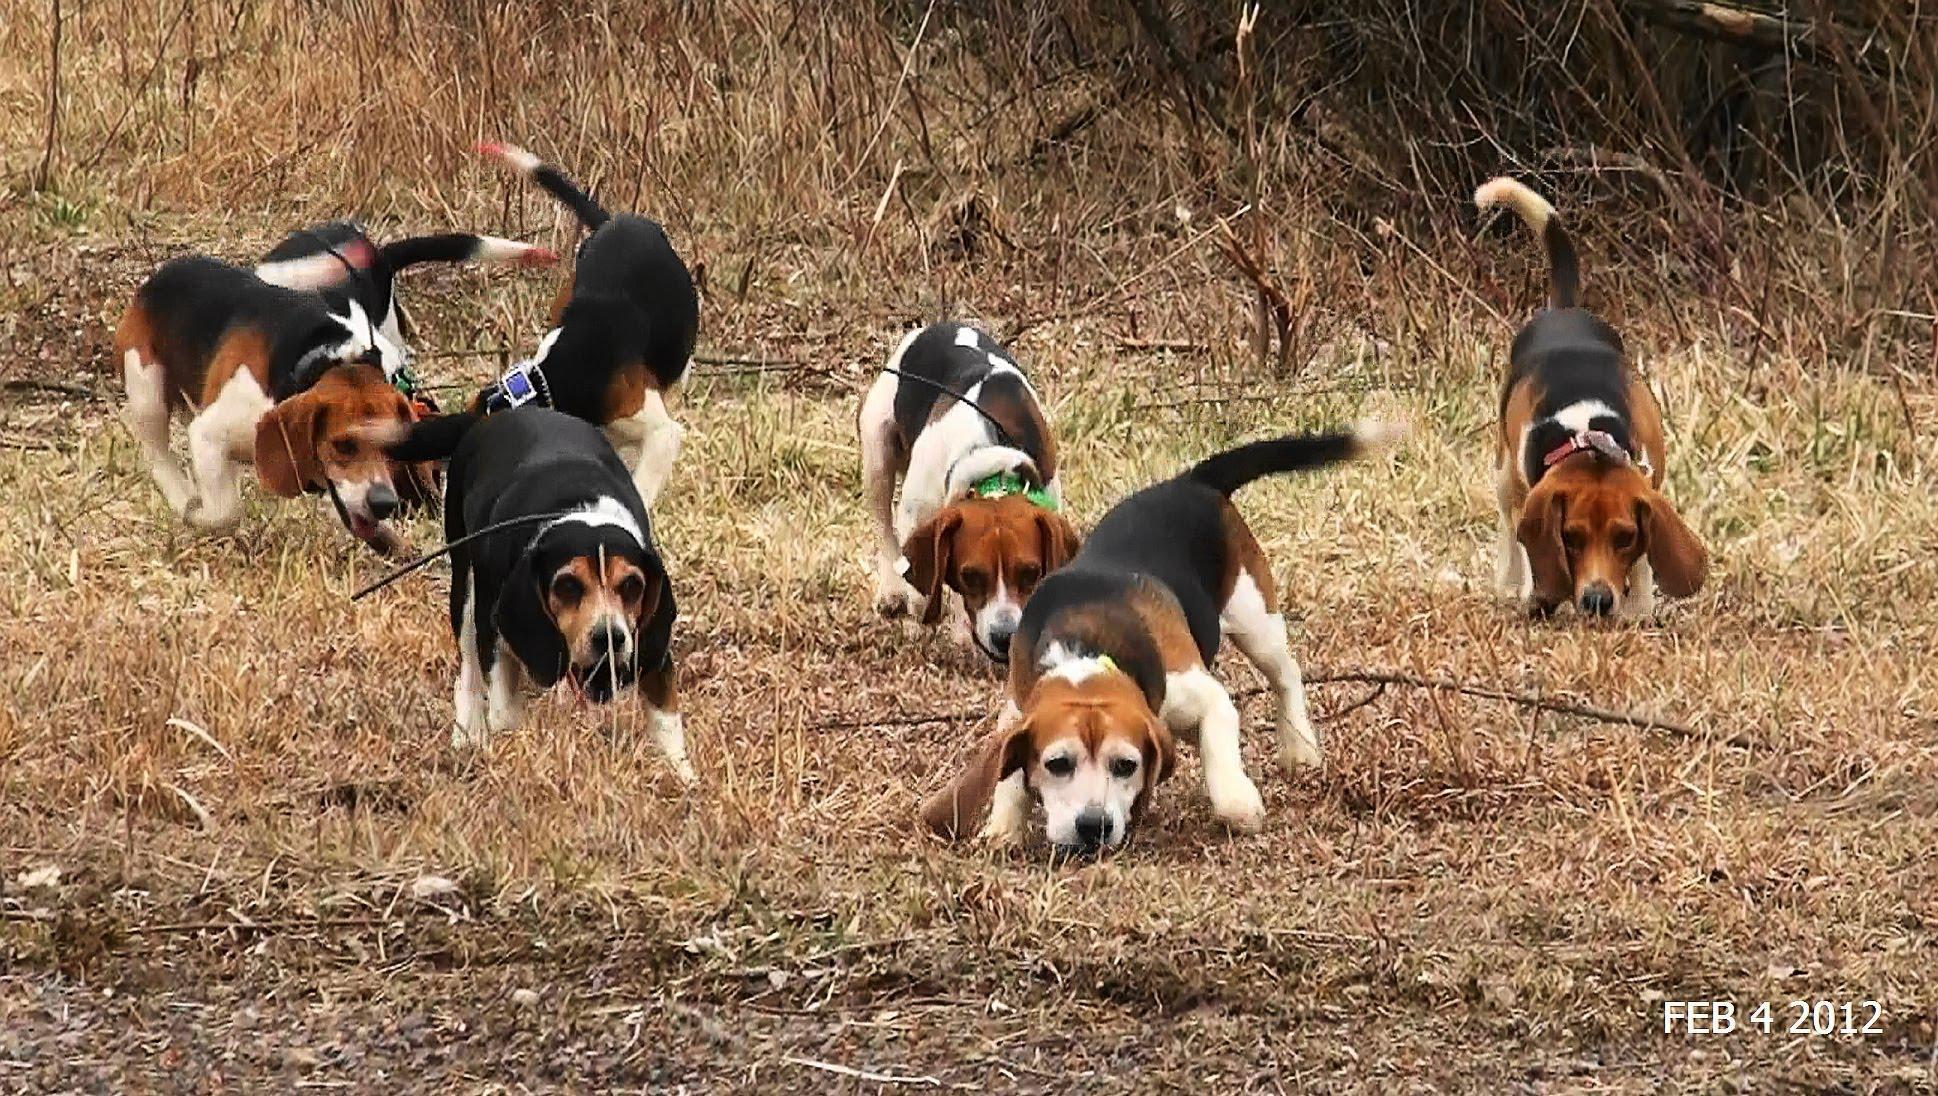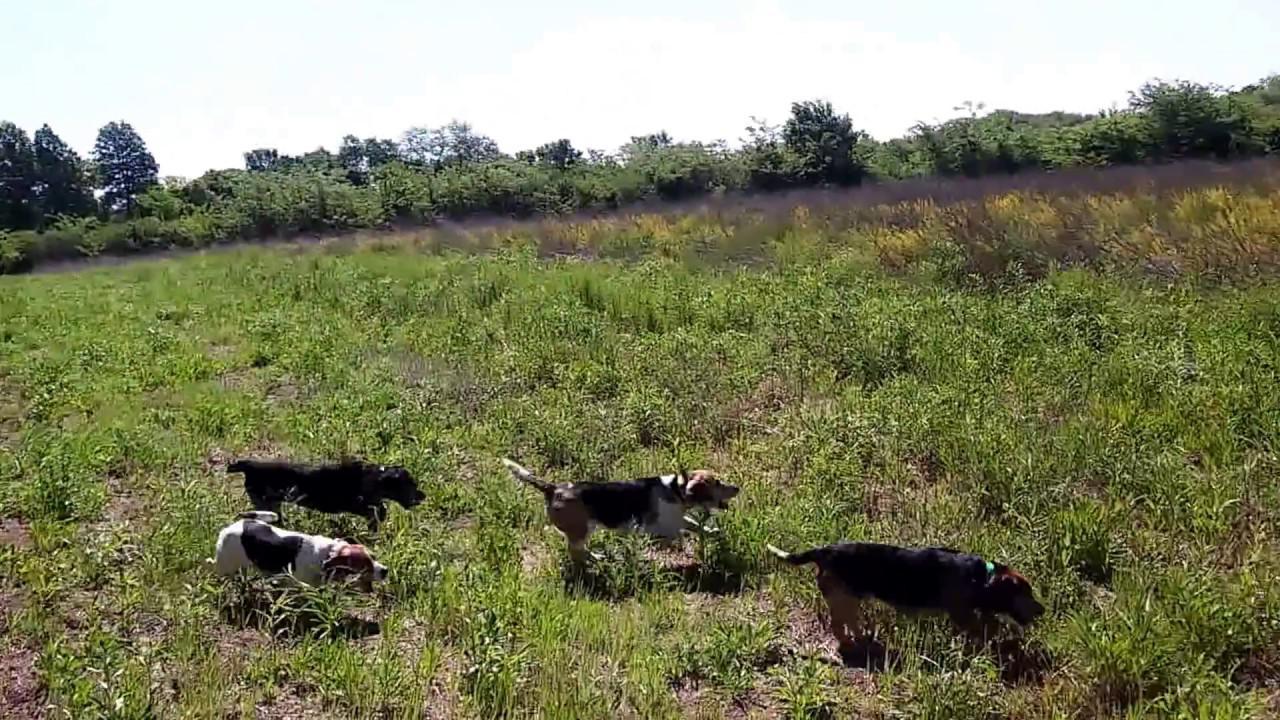The first image is the image on the left, the second image is the image on the right. For the images shown, is this caption "There is no more than one human in the right image." true? Answer yes or no. No. The first image is the image on the left, the second image is the image on the right. Examine the images to the left and right. Is the description "One of the images shows a single man surrounded by a group of hunting dogs." accurate? Answer yes or no. No. 